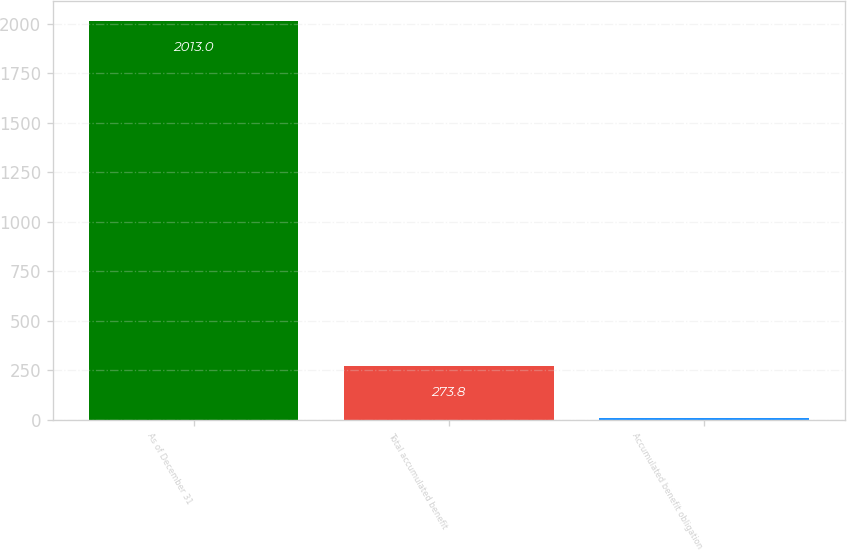Convert chart to OTSL. <chart><loc_0><loc_0><loc_500><loc_500><bar_chart><fcel>As of December 31<fcel>Total accumulated benefit<fcel>Accumulated benefit obligation<nl><fcel>2013<fcel>273.8<fcel>8.8<nl></chart> 